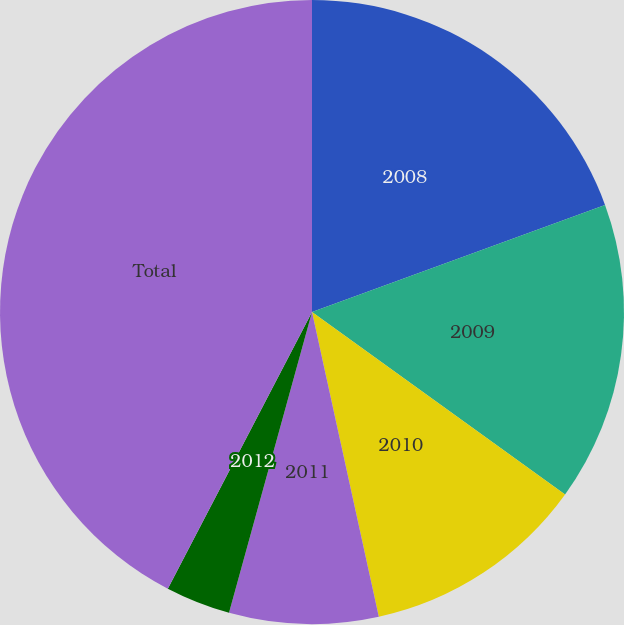Convert chart. <chart><loc_0><loc_0><loc_500><loc_500><pie_chart><fcel>2008<fcel>2009<fcel>2010<fcel>2011<fcel>2012<fcel>Total<nl><fcel>19.42%<fcel>15.52%<fcel>11.62%<fcel>7.72%<fcel>3.36%<fcel>42.35%<nl></chart> 